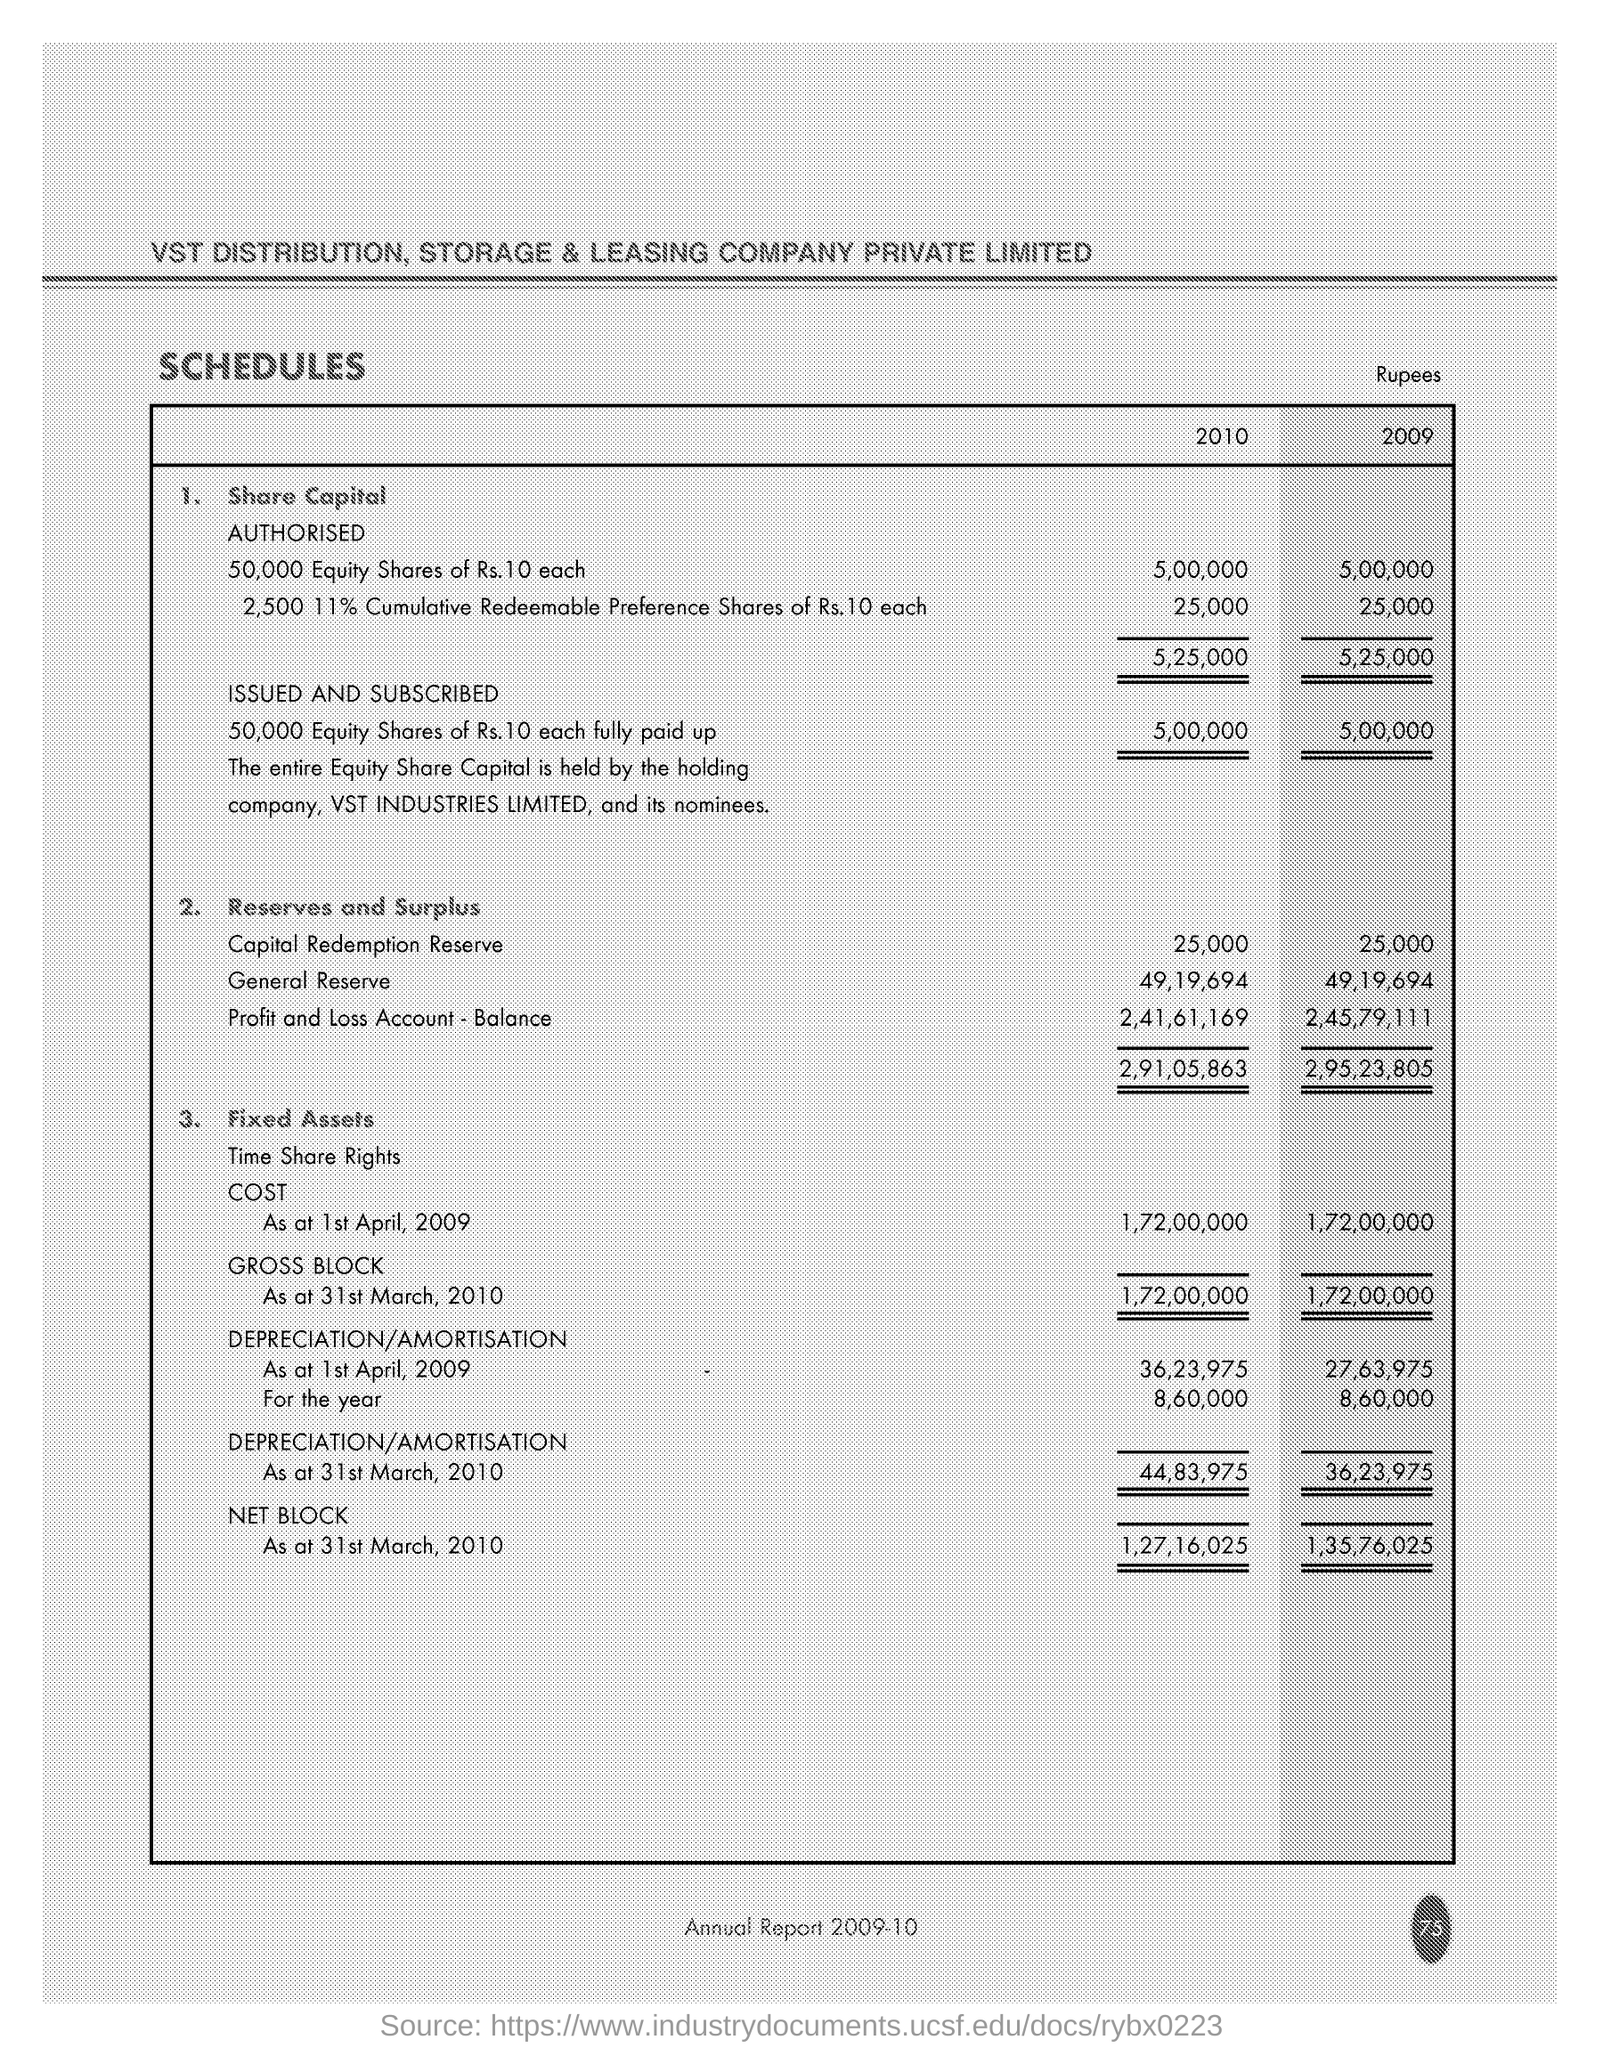What is the Company Name ?
Provide a succinct answer. VST DISTRIBUTION. How much General Reserve in 2009 ?
Your response must be concise. 49,19,694. How much Capital Redemption Reserve in 2010 ?
Make the answer very short. 25,000. 